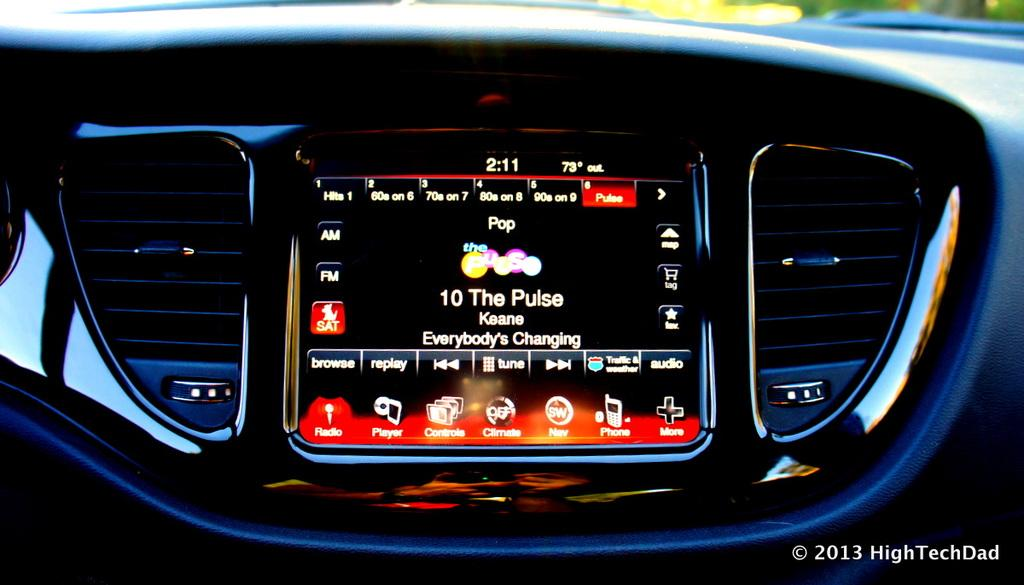What is depicted in the image? The image shows the internal structure of a vehicle. Are there any additional elements present in the image? Yes, there is a watermark and a screen in the image. How many friends can be seen playing with the donkey in the image? There are no friends or donkeys present in the image; it shows the internal structure of a vehicle. 